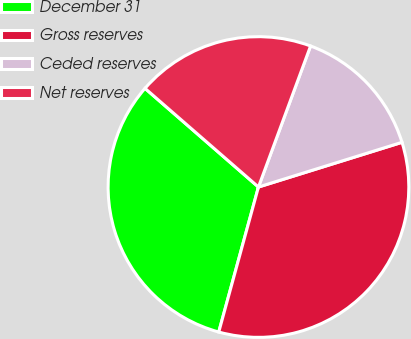Convert chart. <chart><loc_0><loc_0><loc_500><loc_500><pie_chart><fcel>December 31<fcel>Gross reserves<fcel>Ceded reserves<fcel>Net reserves<nl><fcel>32.14%<fcel>34.06%<fcel>14.56%<fcel>19.24%<nl></chart> 